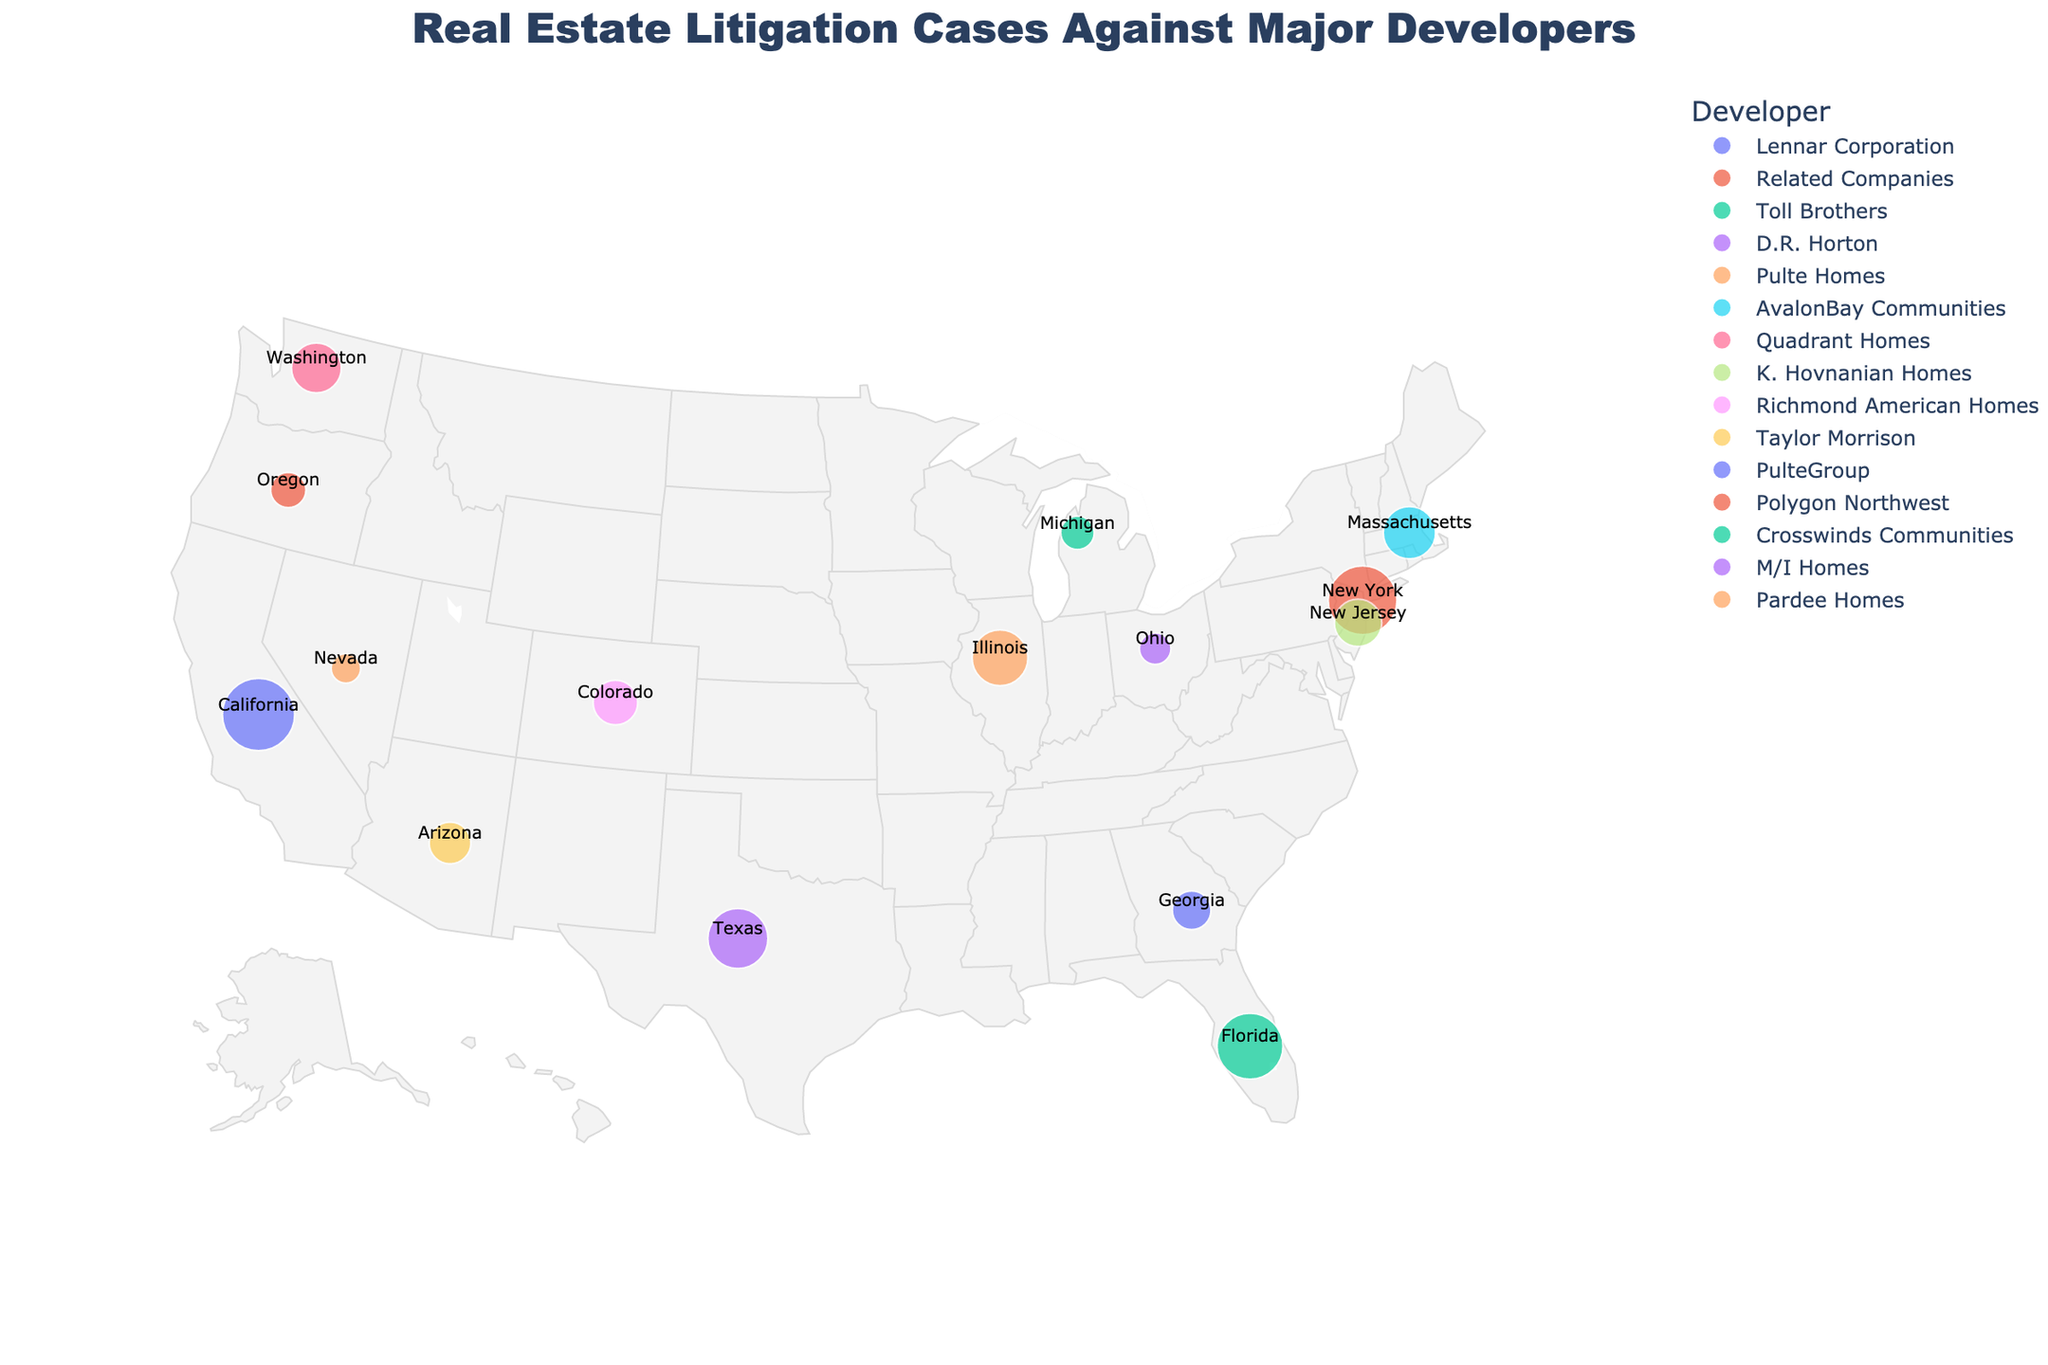How many states are represented in the figure? The figure maps litigation cases in various states. Counting the unique states provided in the data: California, New York, Florida, Texas, Illinois, Massachusetts, Washington, New Jersey, Colorado, Arizona, Georgia, Oregon, Michigan, Ohio, Nevada, we get a total of 15 states.
Answer: 15 Which developer has the most litigation cases? By examining the size of the circles and the number of cases in the figure, Lennar Corporation in California has the largest size and the highest number of cases, which is 42.
Answer: Lennar Corporation How many litigation cases are there in total for the top three states? The top three states with the most litigation cases are California (42 cases), New York (38 cases), and Florida (35 cases). Adding these up: 42 + 38 + 35 = 115.
Answer: 115 Which state has fewer litigation cases, Ohio or Michigan? By looking at the figure, Ohio is represented with 8 cases and Michigan with 9 cases. Thus, Ohio has fewer litigation cases than Michigan.
Answer: Ohio What is the average number of litigation cases across all states? Summing up all the litigation cases from each state: 42 + 38 + 35 + 29 + 25 + 22 + 20 + 18 + 16 + 14 + 12 + 10 + 9 + 8 + 7 = 305. Dividing by the number of states (15): 305 / 15 = 20.33.
Answer: 20.33 How do the number of cases in Texas compare to those in Illinois? The figure shows that Texas has 29 cases and Illinois has 25 cases. Therefore, Texas has 4 more cases than Illinois.
Answer: 4 more cases Which developer appears in the state with the lowest number of litigation cases? The lowest number of litigation cases is in Nevada with 7 cases. According to the figure, the developer in Nevada is Pardee Homes.
Answer: Pardee Homes What is the combined total of litigation cases in the states located on the West Coast (California, Oregon, Washington)? In the figure, California has 42, Oregon has 10, and Washington has 20 cases. The total is 42 + 10 + 20 = 72.
Answer: 72 Is there a state with exactly double the number of cases as another state? If so, which states are they? By examining the number of cases, Massachusetts has 22 cases, and Oregon has 10 cases. Massachusetts has more than double the cases of Oregon.
Answer: Massachusetts, Oregon 